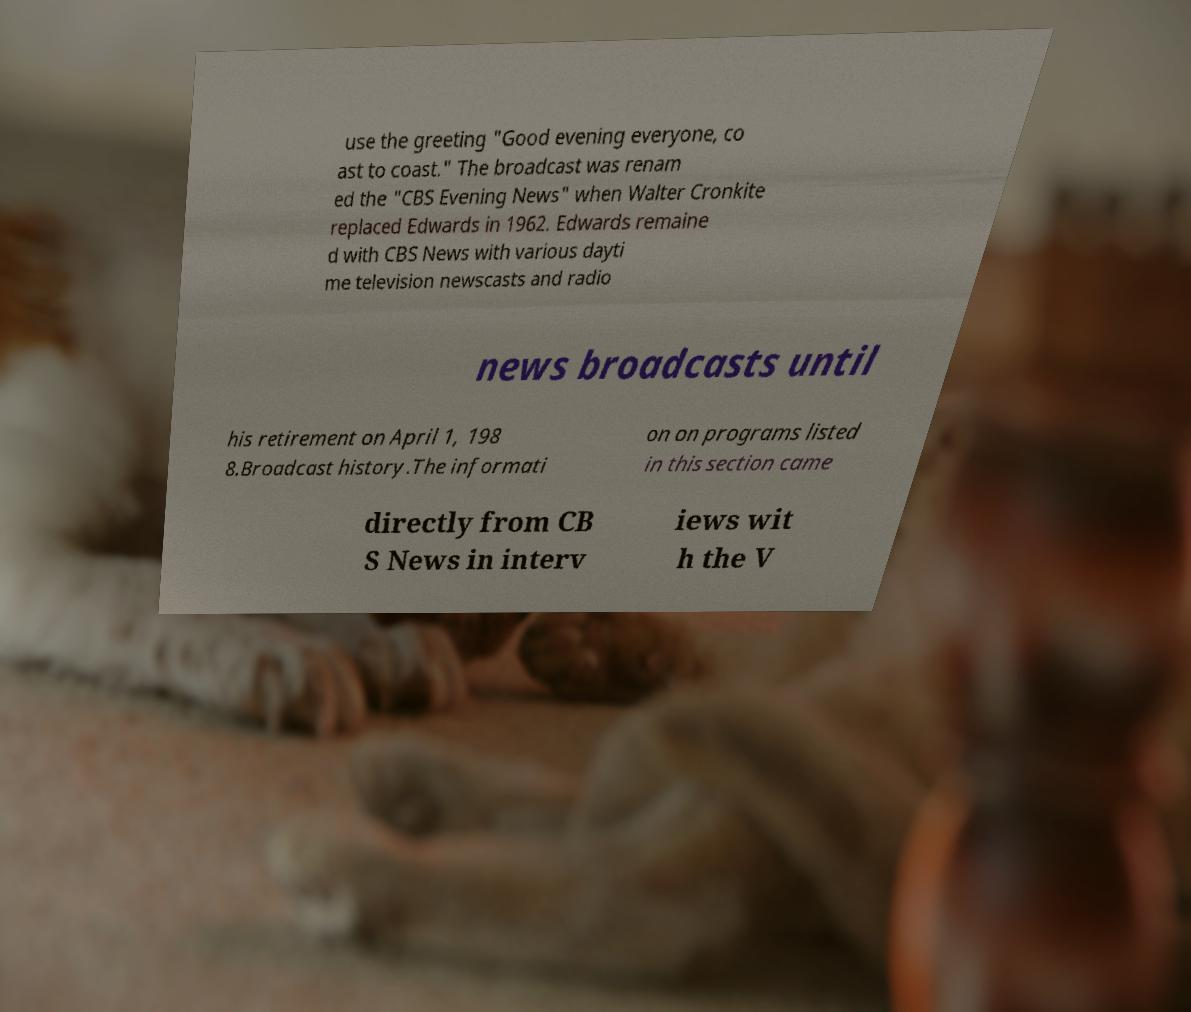Could you extract and type out the text from this image? use the greeting "Good evening everyone, co ast to coast." The broadcast was renam ed the "CBS Evening News" when Walter Cronkite replaced Edwards in 1962. Edwards remaine d with CBS News with various dayti me television newscasts and radio news broadcasts until his retirement on April 1, 198 8.Broadcast history.The informati on on programs listed in this section came directly from CB S News in interv iews wit h the V 